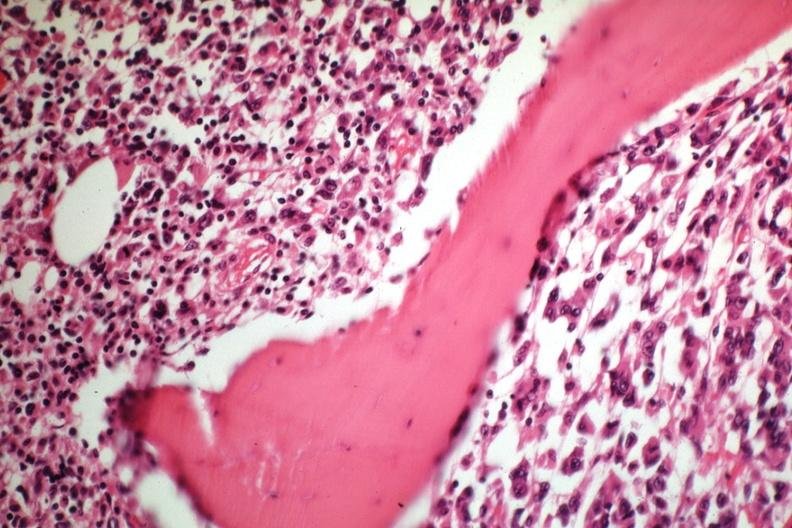what is tumor well shown gross?
Answer the question using a single word or phrase. Slide 